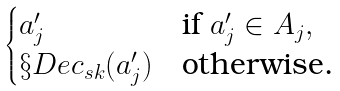<formula> <loc_0><loc_0><loc_500><loc_500>\begin{cases} a ^ { \prime } _ { j } & \text {if } a ^ { \prime } _ { j } \in A _ { j } , \\ \S D e c _ { s k } ( a ^ { \prime } _ { j } ) & \text {otherwise.} \end{cases}</formula> 